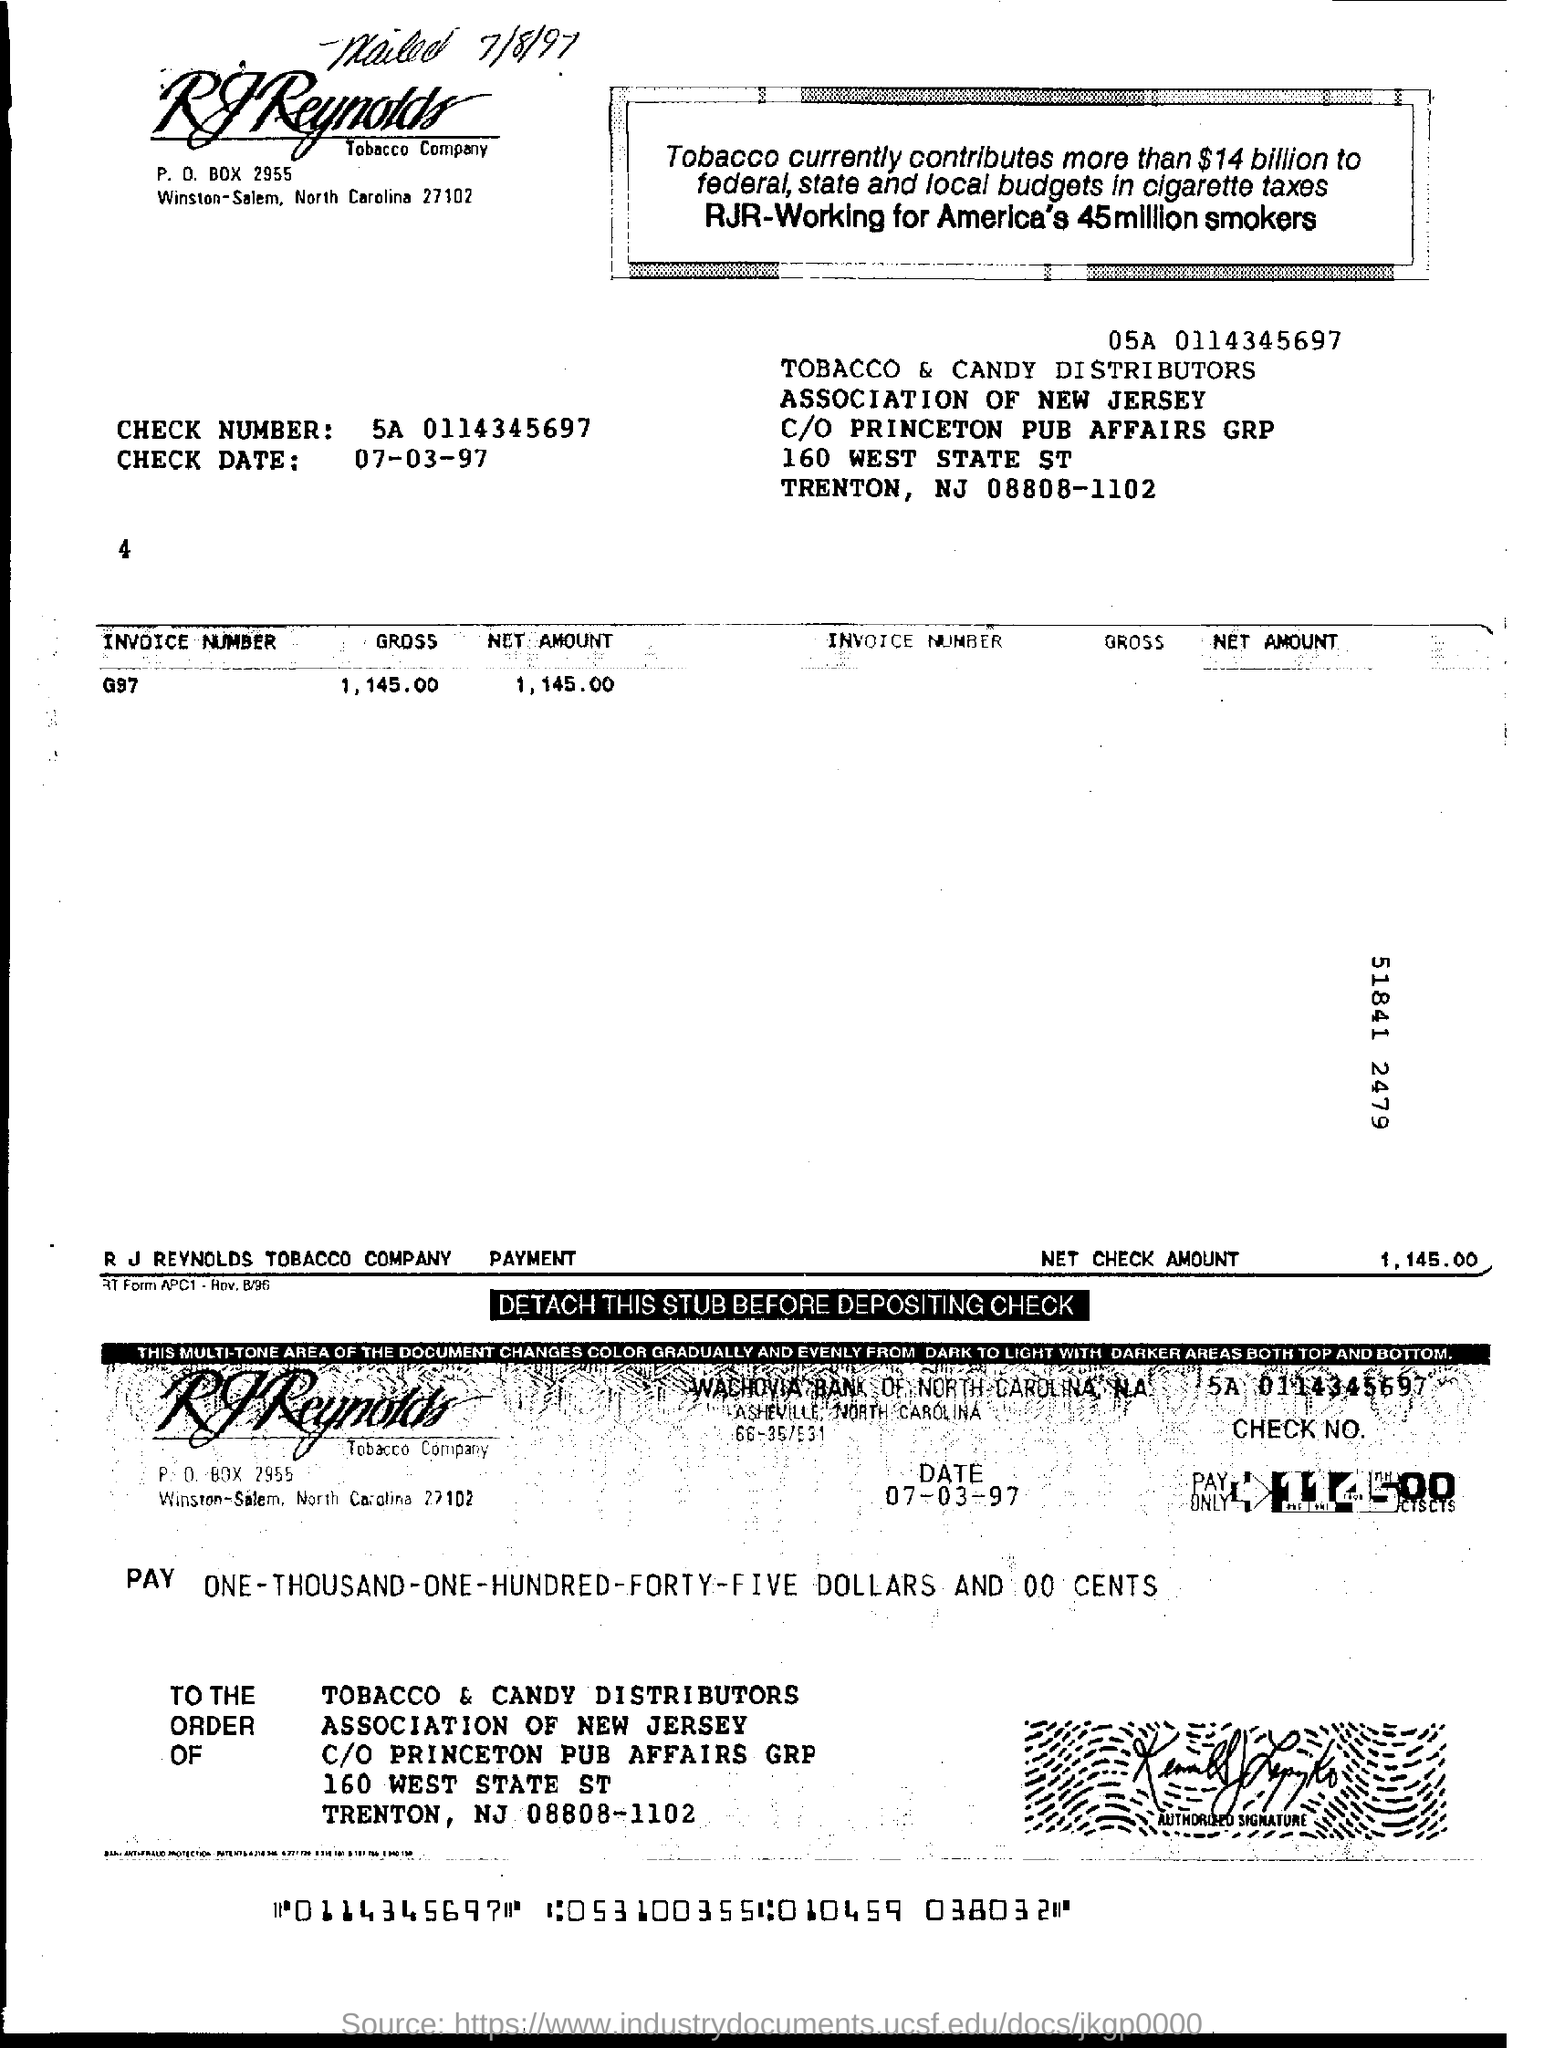Draw attention to some important aspects in this diagram. The net check amount mentioned in the invoice is 1,450.00. The check number mentioned on the invoice is 5A 0114345697. The check date mentioned in the invoice is March 7, 1997. 